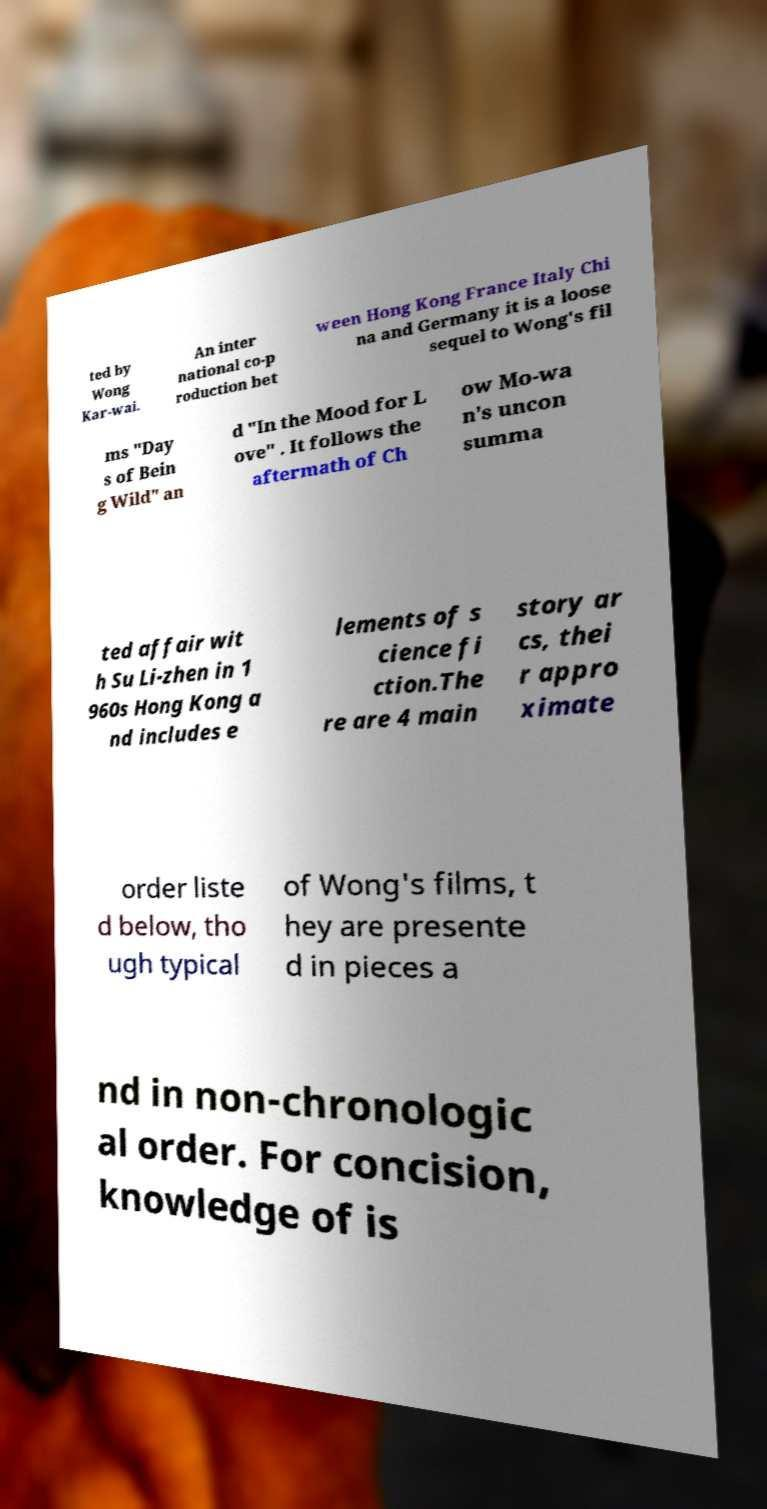Please read and relay the text visible in this image. What does it say? ted by Wong Kar-wai. An inter national co-p roduction bet ween Hong Kong France Italy Chi na and Germany it is a loose sequel to Wong's fil ms "Day s of Bein g Wild" an d "In the Mood for L ove" . It follows the aftermath of Ch ow Mo-wa n's uncon summa ted affair wit h Su Li-zhen in 1 960s Hong Kong a nd includes e lements of s cience fi ction.The re are 4 main story ar cs, thei r appro ximate order liste d below, tho ugh typical of Wong's films, t hey are presente d in pieces a nd in non-chronologic al order. For concision, knowledge of is 